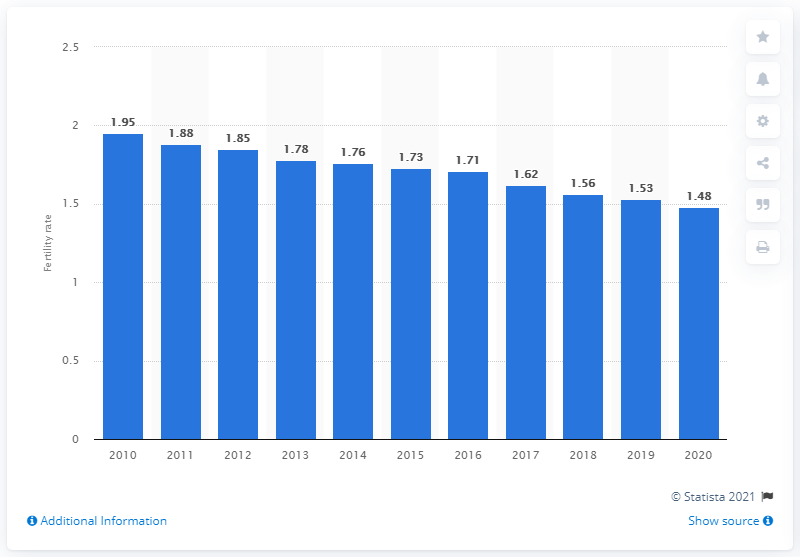Point out several critical features in this image. As of 2020, the fertility rate in Norway is 1.48. 